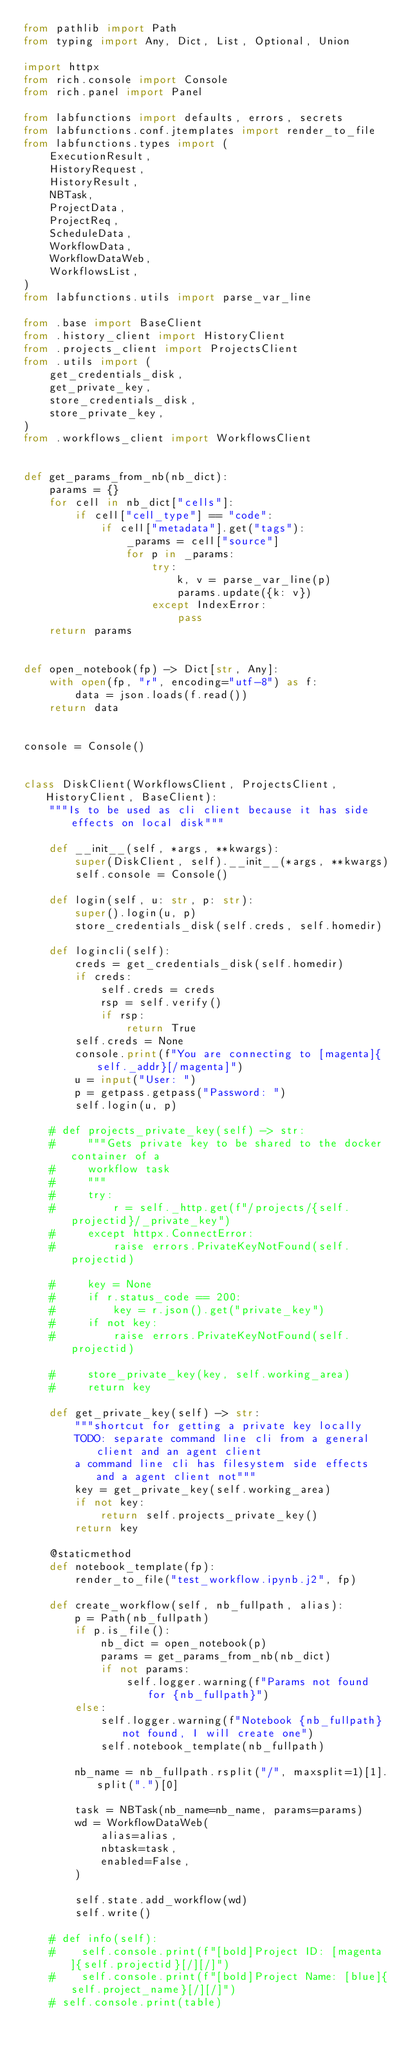<code> <loc_0><loc_0><loc_500><loc_500><_Python_>from pathlib import Path
from typing import Any, Dict, List, Optional, Union

import httpx
from rich.console import Console
from rich.panel import Panel

from labfunctions import defaults, errors, secrets
from labfunctions.conf.jtemplates import render_to_file
from labfunctions.types import (
    ExecutionResult,
    HistoryRequest,
    HistoryResult,
    NBTask,
    ProjectData,
    ProjectReq,
    ScheduleData,
    WorkflowData,
    WorkflowDataWeb,
    WorkflowsList,
)
from labfunctions.utils import parse_var_line

from .base import BaseClient
from .history_client import HistoryClient
from .projects_client import ProjectsClient
from .utils import (
    get_credentials_disk,
    get_private_key,
    store_credentials_disk,
    store_private_key,
)
from .workflows_client import WorkflowsClient


def get_params_from_nb(nb_dict):
    params = {}
    for cell in nb_dict["cells"]:
        if cell["cell_type"] == "code":
            if cell["metadata"].get("tags"):
                _params = cell["source"]
                for p in _params:
                    try:
                        k, v = parse_var_line(p)
                        params.update({k: v})
                    except IndexError:
                        pass
    return params


def open_notebook(fp) -> Dict[str, Any]:
    with open(fp, "r", encoding="utf-8") as f:
        data = json.loads(f.read())
    return data


console = Console()


class DiskClient(WorkflowsClient, ProjectsClient, HistoryClient, BaseClient):
    """Is to be used as cli client because it has side effects on local disk"""

    def __init__(self, *args, **kwargs):
        super(DiskClient, self).__init__(*args, **kwargs)
        self.console = Console()

    def login(self, u: str, p: str):
        super().login(u, p)
        store_credentials_disk(self.creds, self.homedir)

    def logincli(self):
        creds = get_credentials_disk(self.homedir)
        if creds:
            self.creds = creds
            rsp = self.verify()
            if rsp:
                return True
        self.creds = None
        console.print(f"You are connecting to [magenta]{self._addr}[/magenta]")
        u = input("User: ")
        p = getpass.getpass("Password: ")
        self.login(u, p)

    # def projects_private_key(self) -> str:
    #     """Gets private key to be shared to the docker container of a
    #     workflow task
    #     """
    #     try:
    #         r = self._http.get(f"/projects/{self.projectid}/_private_key")
    #     except httpx.ConnectError:
    #         raise errors.PrivateKeyNotFound(self.projectid)

    #     key = None
    #     if r.status_code == 200:
    #         key = r.json().get("private_key")
    #     if not key:
    #         raise errors.PrivateKeyNotFound(self.projectid)

    #     store_private_key(key, self.working_area)
    #     return key

    def get_private_key(self) -> str:
        """shortcut for getting a private key locally
        TODO: separate command line cli from a general client and an agent client
        a command line cli has filesystem side effects and a agent client not"""
        key = get_private_key(self.working_area)
        if not key:
            return self.projects_private_key()
        return key

    @staticmethod
    def notebook_template(fp):
        render_to_file("test_workflow.ipynb.j2", fp)

    def create_workflow(self, nb_fullpath, alias):
        p = Path(nb_fullpath)
        if p.is_file():
            nb_dict = open_notebook(p)
            params = get_params_from_nb(nb_dict)
            if not params:
                self.logger.warning(f"Params not found for {nb_fullpath}")
        else:
            self.logger.warning(f"Notebook {nb_fullpath} not found, I will create one")
            self.notebook_template(nb_fullpath)

        nb_name = nb_fullpath.rsplit("/", maxsplit=1)[1].split(".")[0]

        task = NBTask(nb_name=nb_name, params=params)
        wd = WorkflowDataWeb(
            alias=alias,
            nbtask=task,
            enabled=False,
        )

        self.state.add_workflow(wd)
        self.write()

    # def info(self):
    #    self.console.print(f"[bold]Project ID: [magenta]{self.projectid}[/][/]")
    #    self.console.print(f"[bold]Project Name: [blue]{self.project_name}[/][/]")
    # self.console.print(table)
</code> 